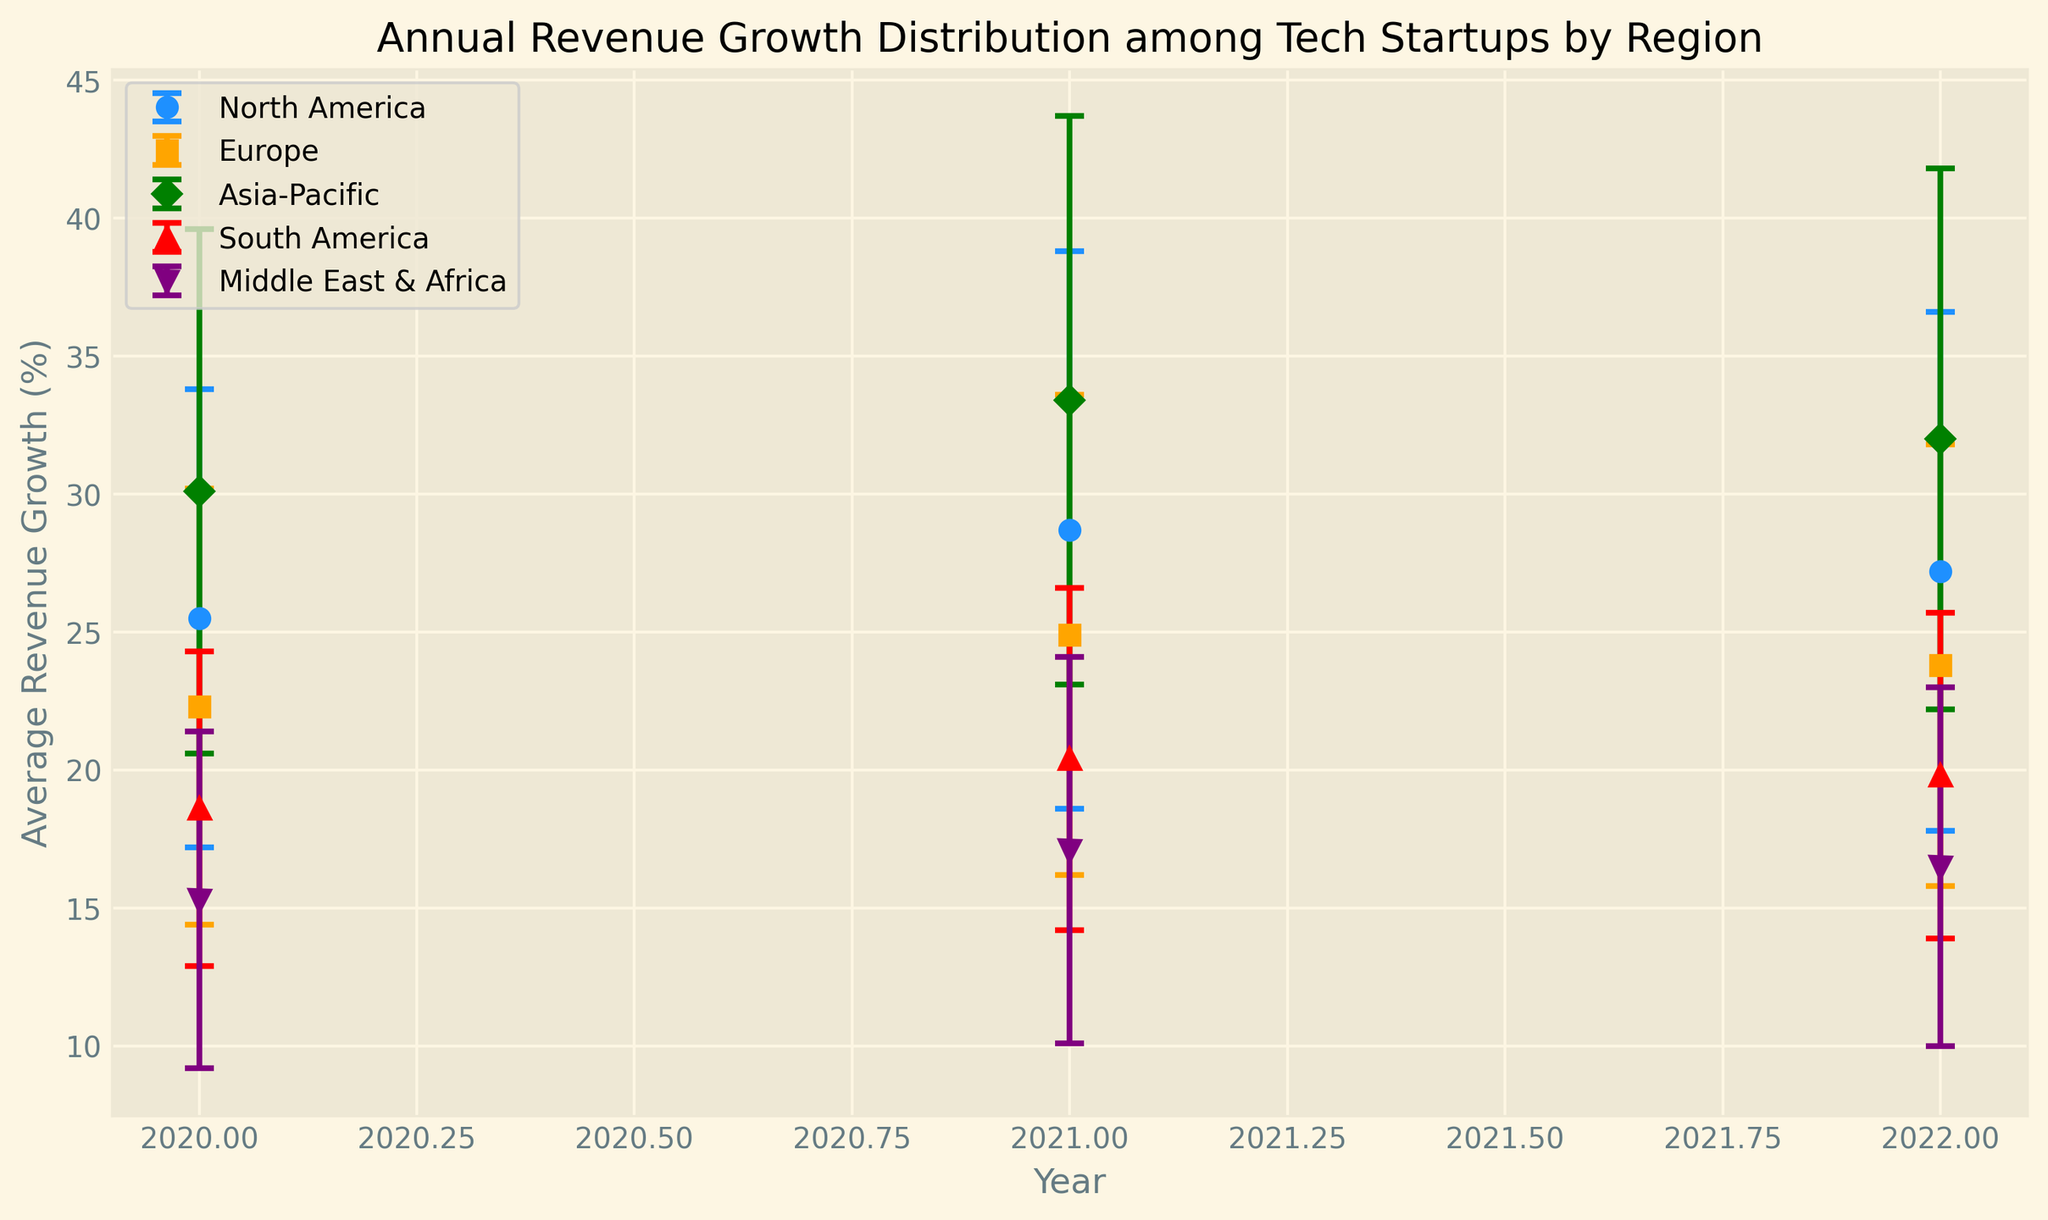Which region had the highest average revenue growth in 2022? The plot shows different colored markers for each region, with error bars representing the standard deviation. For 2022, the highest marker is seen for the Asia-Pacific region.
Answer: Asia-Pacific What is the difference in average revenue growth between North America and Europe in 2021? From the plot, identify the markers for North America and Europe in 2021. North America has an average growth of 28.7%, and Europe has 24.9%. The difference is 28.7 - 24.9.
Answer: 3.8% Which region showed the most consistent (least variability) revenue growth from 2020 to 2022? The plot's error bars show the variability. Look for the region with the shortest error bars over the three years. The shortest error bars are for South America.
Answer: South America How did the revenue growth trend for the Middle East & Africa evolve from 2020 to 2022? Observe the markers for the Middle East & Africa for each year. The trend shows an increase from 15.3% in 2020 to 17.1% in 2021, followed by a slight decrease to 16.5% in 2022.
Answer: Increased then slightly decreased Which region experienced the largest average revenue growth increase from 2020 to 2021? Compare the markers for 2020 and 2021 for each region. The Asia-Pacific region shows an increase from 30.1% in 2020 to 33.4% in 2021, an increase of 3.3 percentage points.
Answer: Asia-Pacific What is the average of the average revenue growth percentages for Europe from 2020 to 2022? Identify the average revenue growth values for Europe (22.3%, 24.9%, 23.8%) and calculate their average: (22.3 + 24.9 + 23.8) / 3 = 23.67%.
Answer: 23.67% Which region has the widest range of revenue growth (highest standard deviation) in 2020? Check the length of the error bars for each region in 2020. The largest error bar corresponds to Asia-Pacific with a standard deviation of 9.5%.
Answer: Asia-Pacific Compare the revenue growth trends of North America and South America over the three years. Observe the markers for each region for the three years. North America shows an increasing trend until 2021 and then a slight decrease in 2022. South America shows a consistent but more gradual increase and stabilizes.
Answer: North America increased then slightly decreased, South America increased then stabilized Which year shows the highest overall variability in average revenue growth among the regions? Compare the length of all error bars for each year. In 2021, the error bars are generally the longest, indicating the highest variability.
Answer: 2021 